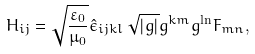<formula> <loc_0><loc_0><loc_500><loc_500>H _ { i j } = \sqrt { \frac { \varepsilon _ { 0 } } { \mu _ { 0 } } } \hat { \epsilon } _ { i j k l } \, \sqrt { | g | } g ^ { k m } g ^ { \ln } F _ { m n } ,</formula> 